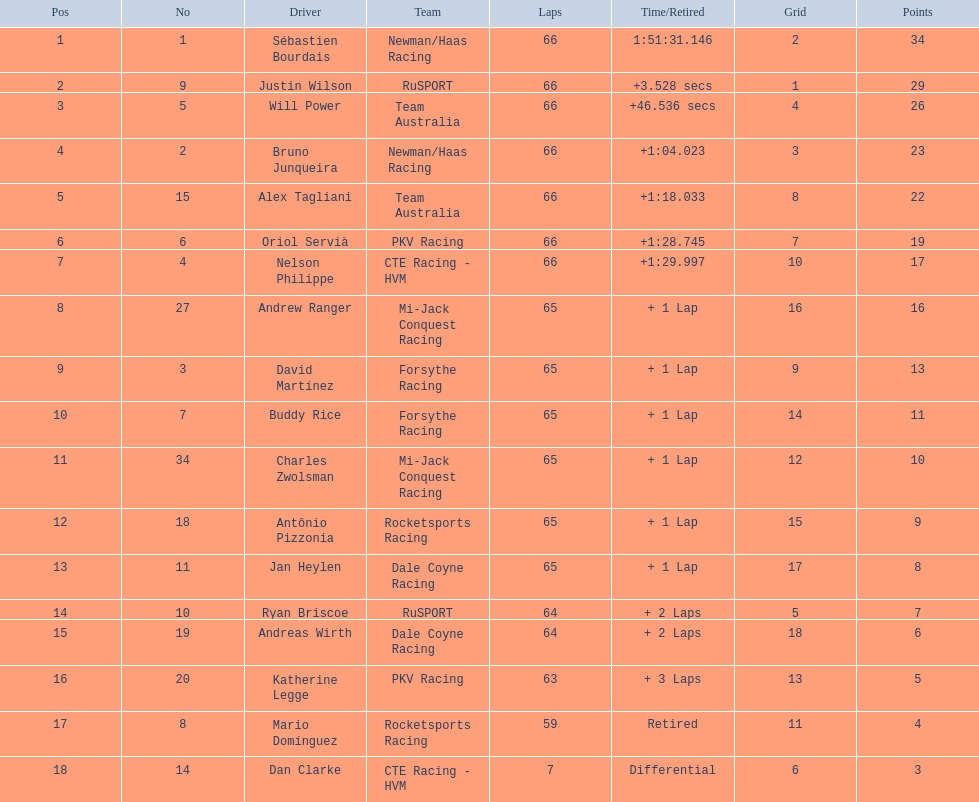What are the drivers' numbers? 1, 9, 5, 2, 15, 6, 4, 27, 3, 7, 34, 18, 11, 10, 19, 20, 8, 14. Do any of them have a number that matches their position? Sébastien Bourdais, Oriol Servià. Among those drivers, who occupies the top position? Sébastien Bourdais. 